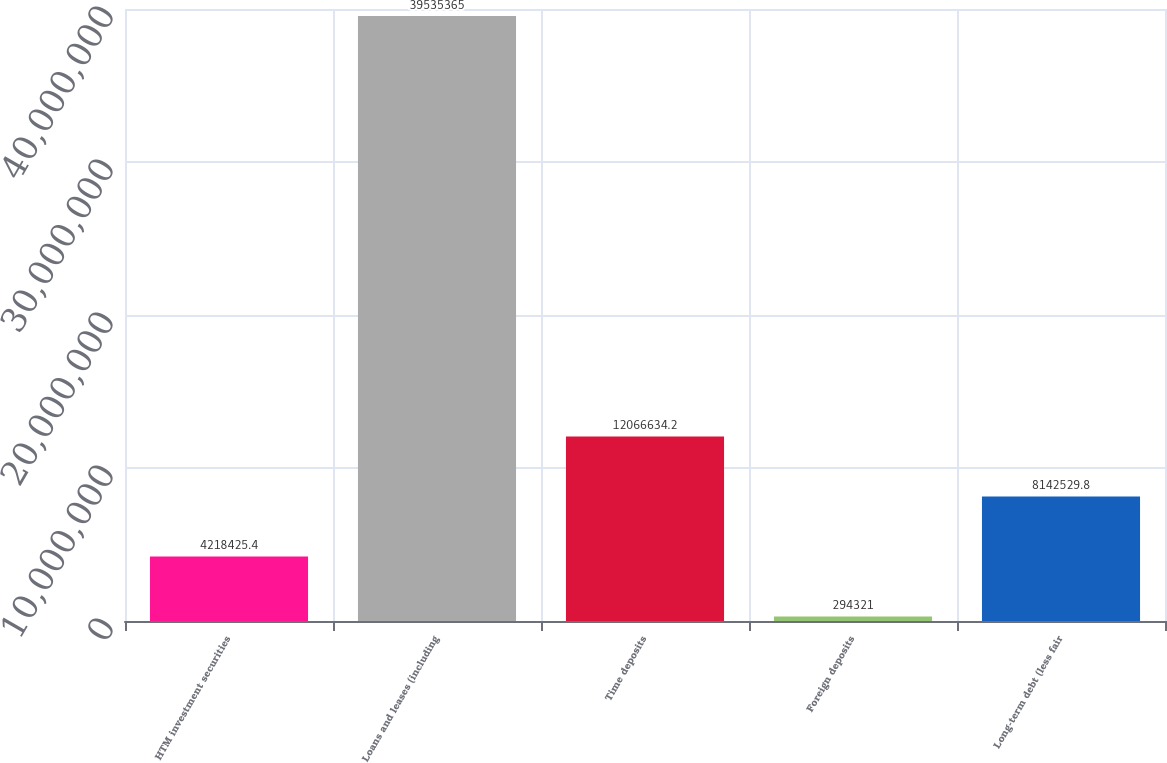<chart> <loc_0><loc_0><loc_500><loc_500><bar_chart><fcel>HTM investment securities<fcel>Loans and leases (including<fcel>Time deposits<fcel>Foreign deposits<fcel>Long-term debt (less fair<nl><fcel>4.21843e+06<fcel>3.95354e+07<fcel>1.20666e+07<fcel>294321<fcel>8.14253e+06<nl></chart> 